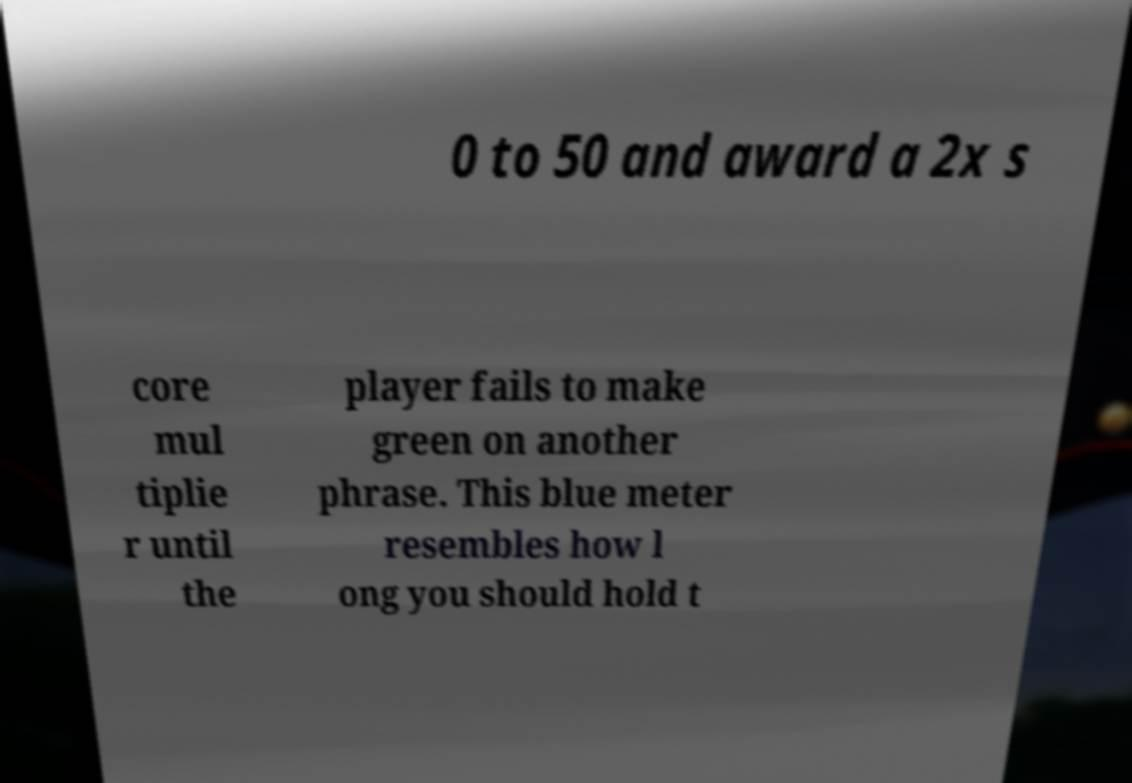What messages or text are displayed in this image? I need them in a readable, typed format. 0 to 50 and award a 2x s core mul tiplie r until the player fails to make green on another phrase. This blue meter resembles how l ong you should hold t 